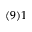Convert formula to latex. <formula><loc_0><loc_0><loc_500><loc_500>( 9 ) 1</formula> 